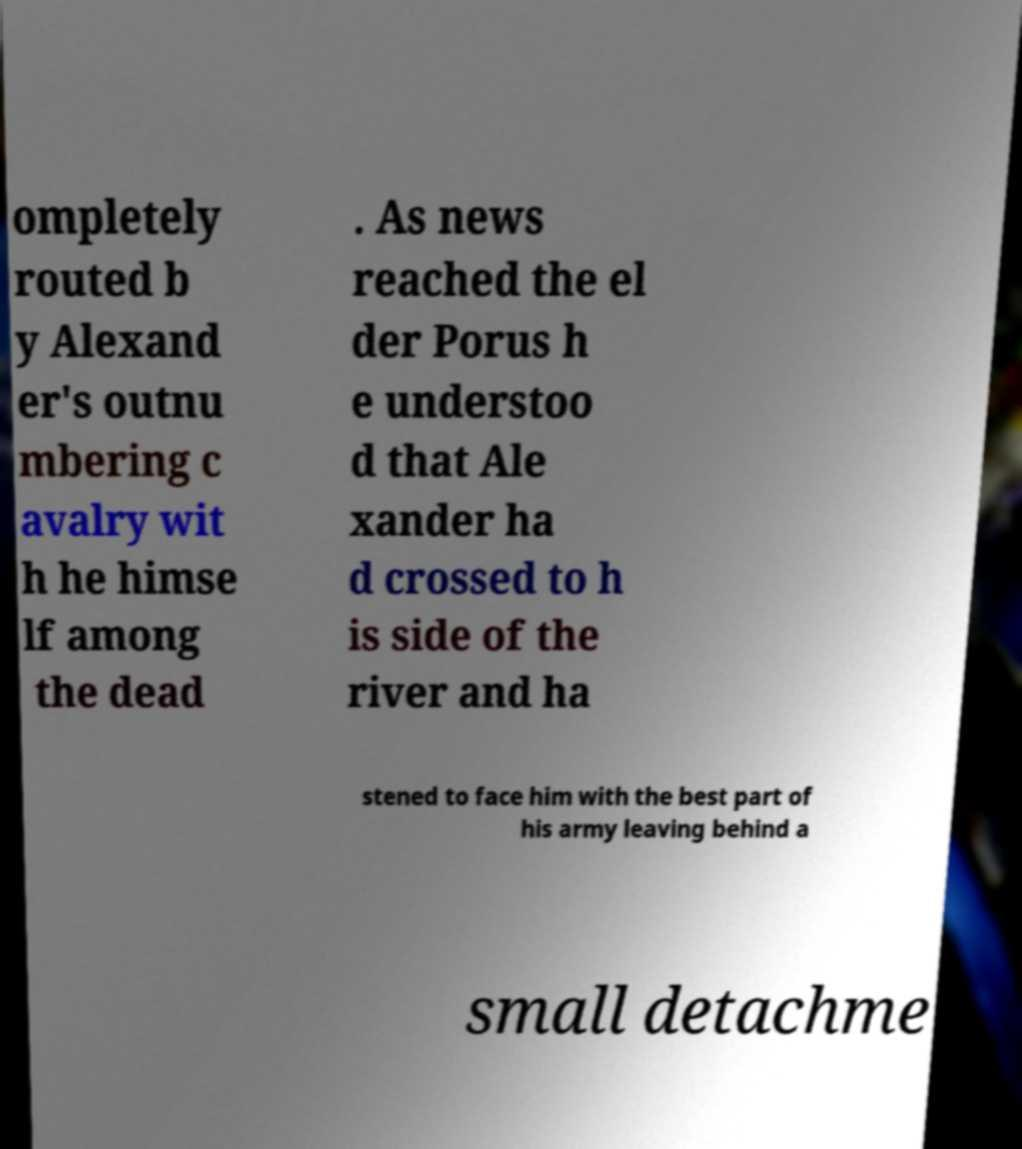For documentation purposes, I need the text within this image transcribed. Could you provide that? ompletely routed b y Alexand er's outnu mbering c avalry wit h he himse lf among the dead . As news reached the el der Porus h e understoo d that Ale xander ha d crossed to h is side of the river and ha stened to face him with the best part of his army leaving behind a small detachme 